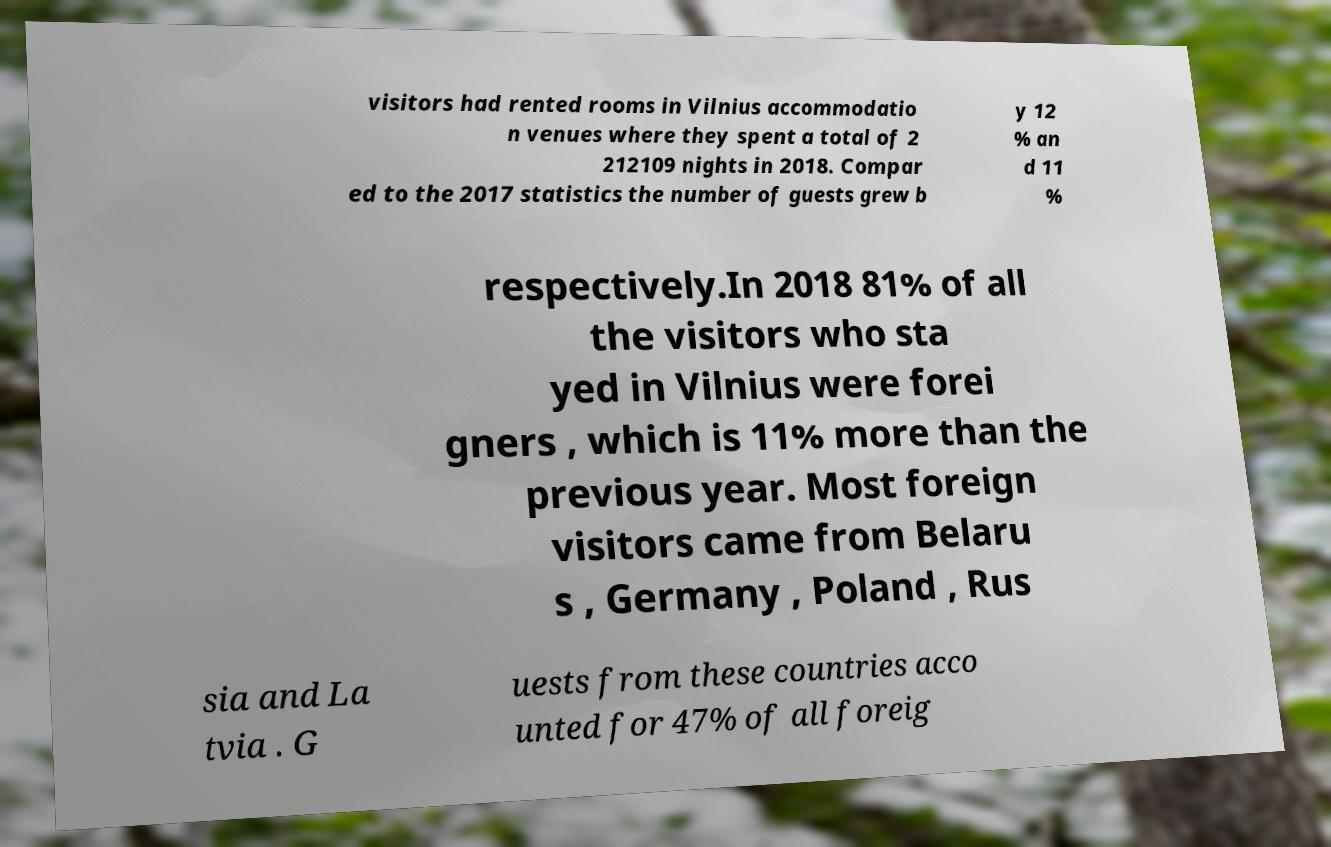Please identify and transcribe the text found in this image. visitors had rented rooms in Vilnius accommodatio n venues where they spent a total of 2 212109 nights in 2018. Compar ed to the 2017 statistics the number of guests grew b y 12 % an d 11 % respectively.In 2018 81% of all the visitors who sta yed in Vilnius were forei gners , which is 11% more than the previous year. Most foreign visitors came from Belaru s , Germany , Poland , Rus sia and La tvia . G uests from these countries acco unted for 47% of all foreig 